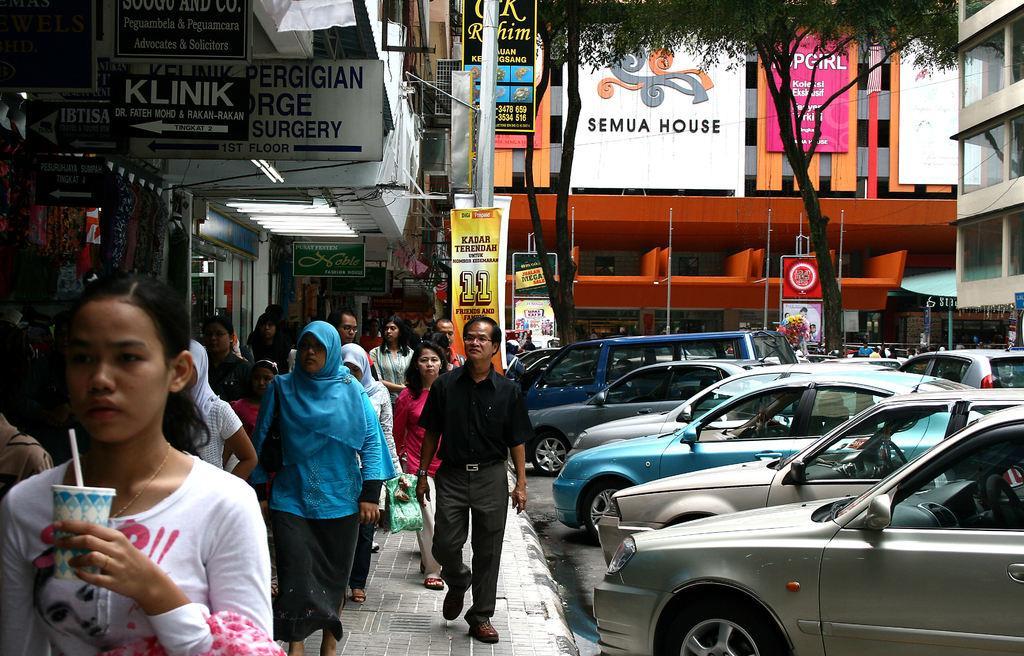Please provide a concise description of this image. In the picture we can see a path near the building shops and on the path we can see many people are walking holding bags and beside them, we can see another building with advertisement boards to it and near to it we can see a tree and some cars are parked on the path. 